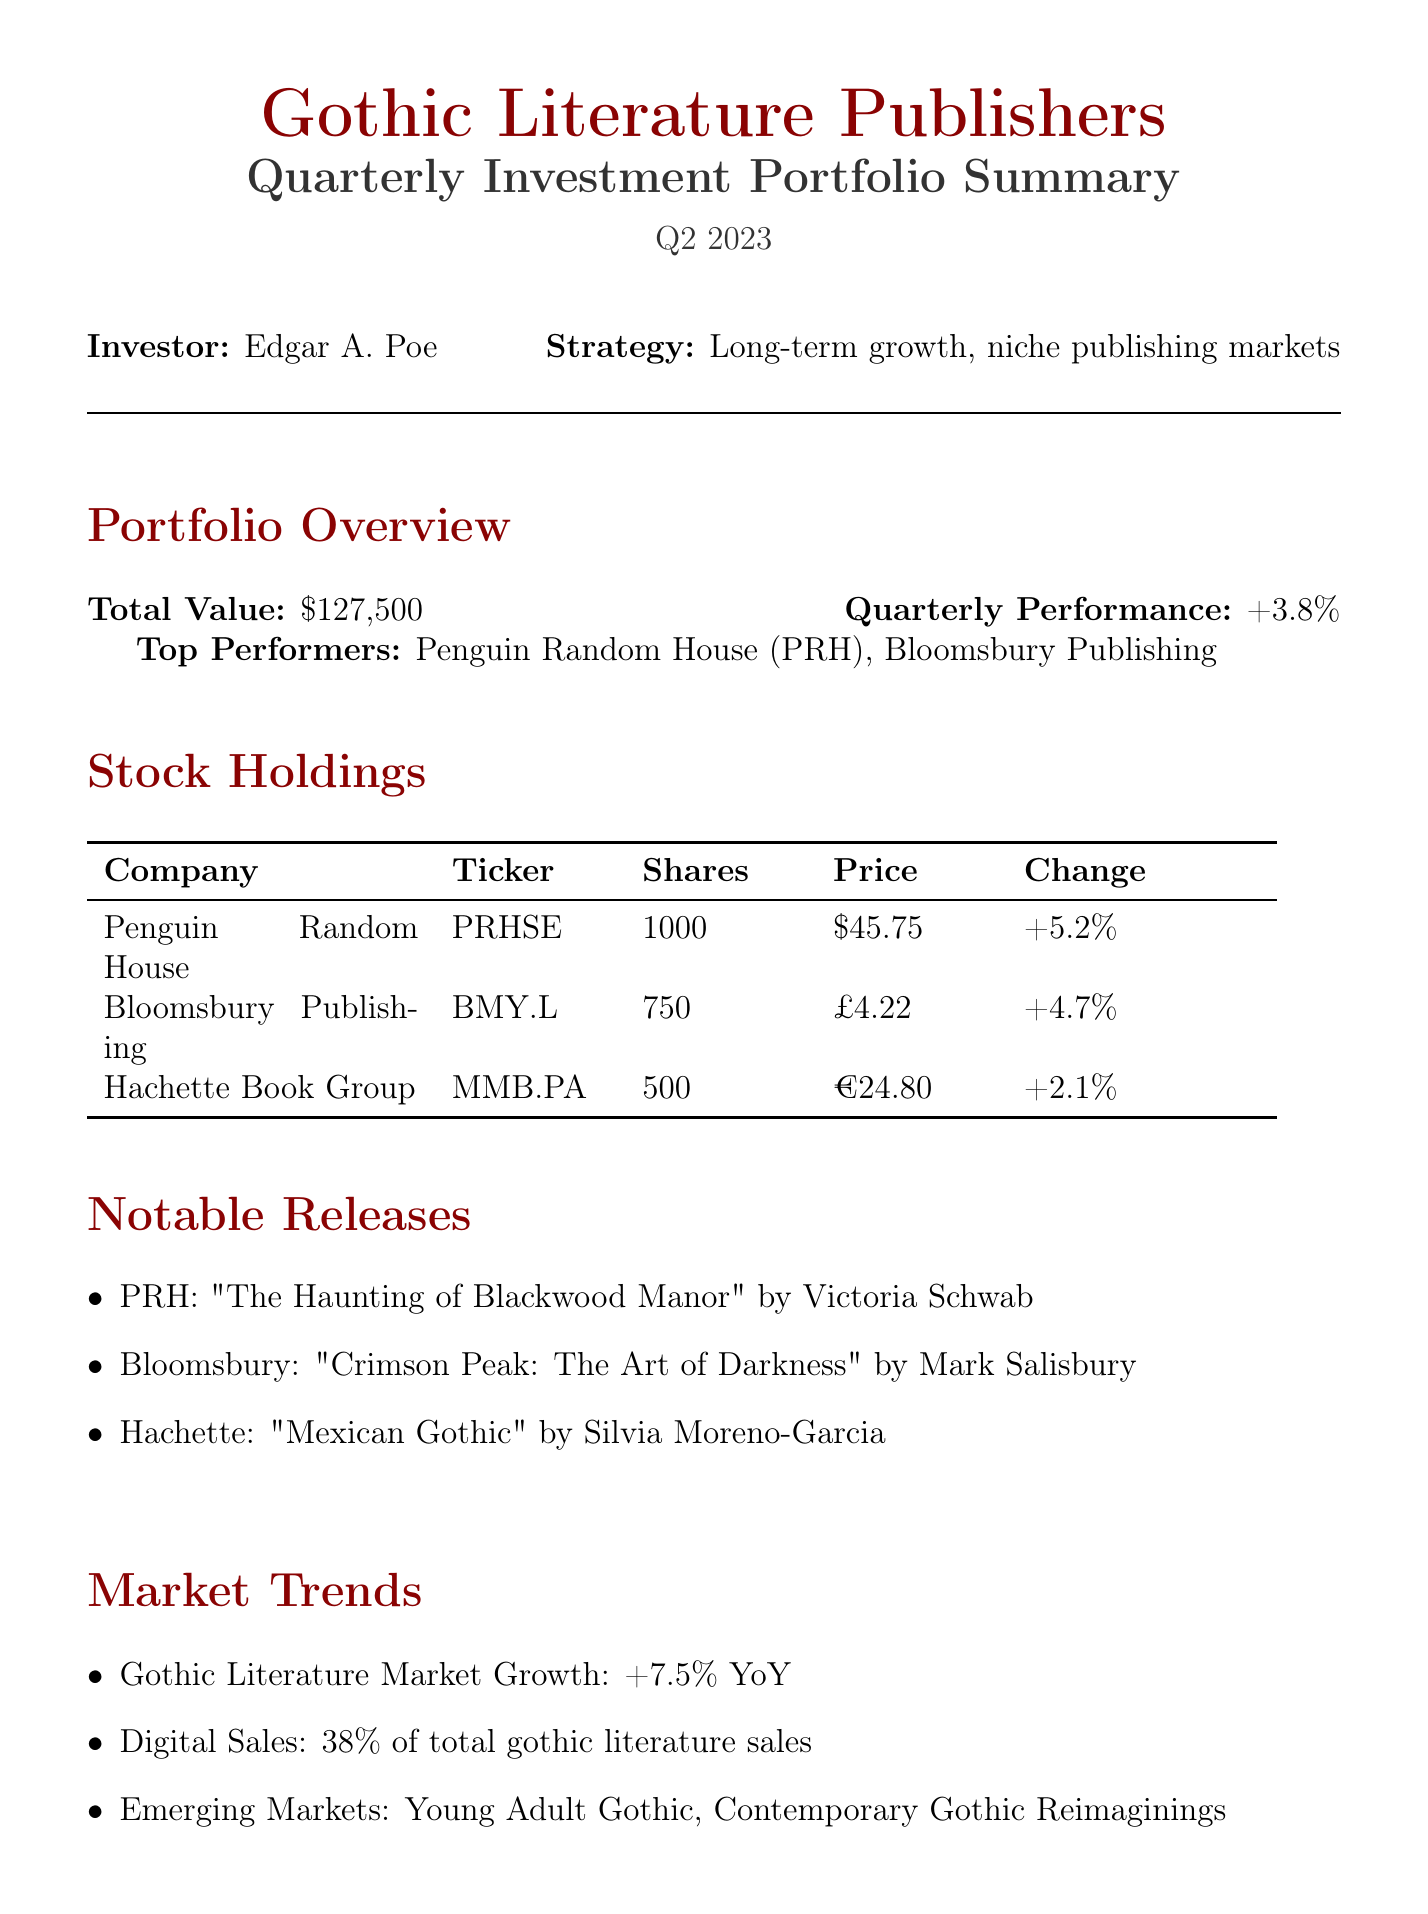What is the total value of the portfolio? The total value is explicitly stated in the document as $127,500.
Answer: $127,500 Who is the investor? The investor's name is listed at the beginning of the document as Edgar A. Poe.
Answer: Edgar A. Poe What is the quarterly performance percentage? The quarterly performance percentage is mentioned in the report as +3.8%.
Answer: +3.8% Which publishing company had the highest quarterly change? The company with the highest quarterly change is highlighted as Penguin Random House with +5.2%.
Answer: Penguin Random House What is the notable release by Bloomsbury Publishing? The notable release from Bloomsbury Publishing is referenced as "Crimson Peak: The Art of Darkness" by Mark Salisbury.
Answer: "Crimson Peak: The Art of Darkness" by Mark Salisbury What is the projected growth for the next quarter? The projected growth for the next quarter is indicated as 5.2%.
Answer: 5.2% What percentage of gothic literature sales are digital? The document states that digital sales account for 38% of total gothic literature sales.
Answer: 38% What potential risk is mentioned in the future outlook? The potential risk indicated is "Increased competition from independent publishers and self-published authors in the gothic genre."
Answer: Increased competition from independent publishers and self-published authors in the gothic genre 